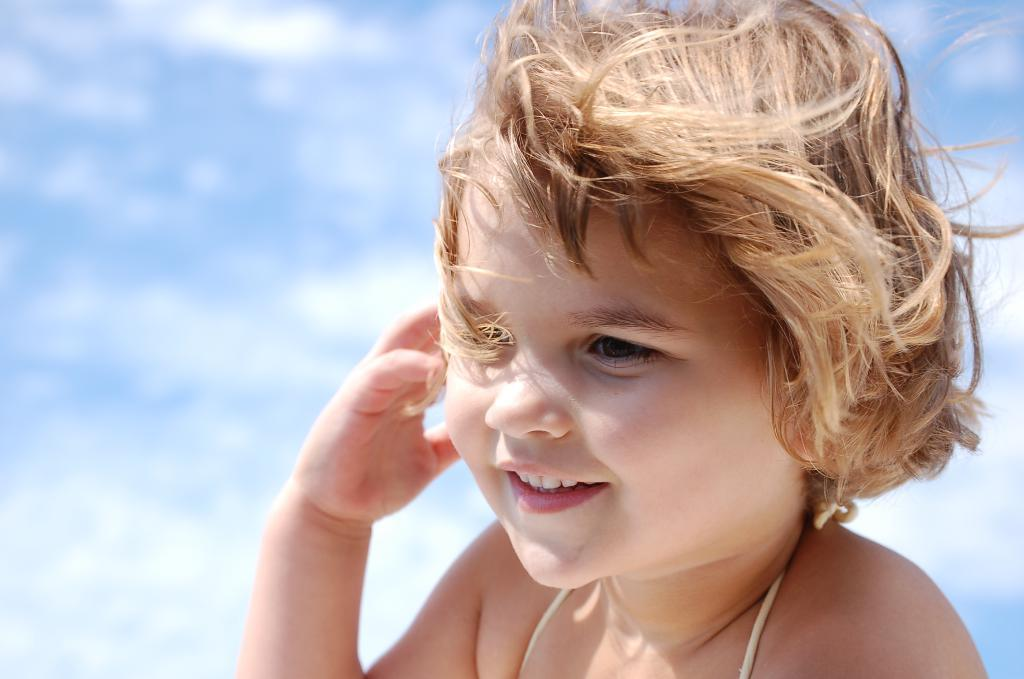Who is present in the image? There is a girl in the image. What is the girl's facial expression? The girl is smiling. Can you describe the background of the girl? The background of the girl is blurred. What type of sofa can be seen in the background of the image? There is no sofa present in the image; the background is blurred. 